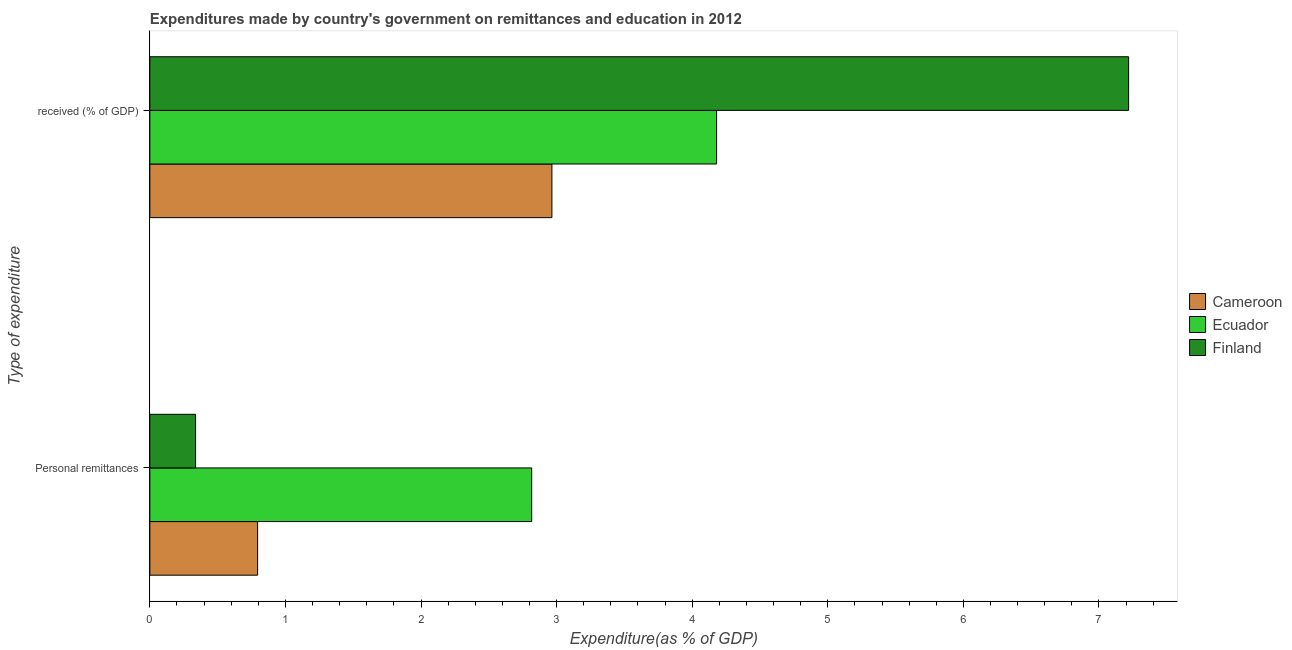Are the number of bars on each tick of the Y-axis equal?
Your response must be concise. Yes. How many bars are there on the 2nd tick from the top?
Offer a very short reply. 3. How many bars are there on the 1st tick from the bottom?
Give a very brief answer. 3. What is the label of the 1st group of bars from the top?
Your answer should be compact.  received (% of GDP). What is the expenditure in education in Ecuador?
Ensure brevity in your answer.  4.18. Across all countries, what is the maximum expenditure in personal remittances?
Provide a short and direct response. 2.82. Across all countries, what is the minimum expenditure in personal remittances?
Provide a short and direct response. 0.34. In which country was the expenditure in education maximum?
Offer a very short reply. Finland. What is the total expenditure in personal remittances in the graph?
Give a very brief answer. 3.95. What is the difference between the expenditure in education in Finland and that in Ecuador?
Give a very brief answer. 3.04. What is the difference between the expenditure in personal remittances in Ecuador and the expenditure in education in Finland?
Your response must be concise. -4.4. What is the average expenditure in education per country?
Offer a terse response. 4.79. What is the difference between the expenditure in personal remittances and expenditure in education in Finland?
Offer a terse response. -6.88. In how many countries, is the expenditure in education greater than 2.2 %?
Your response must be concise. 3. What is the ratio of the expenditure in personal remittances in Ecuador to that in Cameroon?
Give a very brief answer. 3.54. Is the expenditure in education in Cameroon less than that in Ecuador?
Make the answer very short. Yes. What does the 1st bar from the top in Personal remittances represents?
Your response must be concise. Finland. What does the 1st bar from the bottom in Personal remittances represents?
Offer a terse response. Cameroon. How many countries are there in the graph?
Offer a very short reply. 3. Are the values on the major ticks of X-axis written in scientific E-notation?
Ensure brevity in your answer.  No. What is the title of the graph?
Your answer should be compact. Expenditures made by country's government on remittances and education in 2012. Does "Iran" appear as one of the legend labels in the graph?
Your answer should be compact. No. What is the label or title of the X-axis?
Your answer should be compact. Expenditure(as % of GDP). What is the label or title of the Y-axis?
Your answer should be compact. Type of expenditure. What is the Expenditure(as % of GDP) of Cameroon in Personal remittances?
Your answer should be very brief. 0.79. What is the Expenditure(as % of GDP) of Ecuador in Personal remittances?
Your answer should be compact. 2.82. What is the Expenditure(as % of GDP) of Finland in Personal remittances?
Keep it short and to the point. 0.34. What is the Expenditure(as % of GDP) in Cameroon in  received (% of GDP)?
Offer a terse response. 2.97. What is the Expenditure(as % of GDP) in Ecuador in  received (% of GDP)?
Keep it short and to the point. 4.18. What is the Expenditure(as % of GDP) of Finland in  received (% of GDP)?
Your answer should be compact. 7.22. Across all Type of expenditure, what is the maximum Expenditure(as % of GDP) in Cameroon?
Your answer should be compact. 2.97. Across all Type of expenditure, what is the maximum Expenditure(as % of GDP) in Ecuador?
Provide a short and direct response. 4.18. Across all Type of expenditure, what is the maximum Expenditure(as % of GDP) of Finland?
Keep it short and to the point. 7.22. Across all Type of expenditure, what is the minimum Expenditure(as % of GDP) of Cameroon?
Your answer should be compact. 0.79. Across all Type of expenditure, what is the minimum Expenditure(as % of GDP) in Ecuador?
Offer a terse response. 2.82. Across all Type of expenditure, what is the minimum Expenditure(as % of GDP) of Finland?
Your answer should be very brief. 0.34. What is the total Expenditure(as % of GDP) in Cameroon in the graph?
Your answer should be compact. 3.76. What is the total Expenditure(as % of GDP) of Ecuador in the graph?
Make the answer very short. 7. What is the total Expenditure(as % of GDP) in Finland in the graph?
Offer a very short reply. 7.56. What is the difference between the Expenditure(as % of GDP) of Cameroon in Personal remittances and that in  received (% of GDP)?
Offer a very short reply. -2.17. What is the difference between the Expenditure(as % of GDP) of Ecuador in Personal remittances and that in  received (% of GDP)?
Keep it short and to the point. -1.36. What is the difference between the Expenditure(as % of GDP) of Finland in Personal remittances and that in  received (% of GDP)?
Your response must be concise. -6.88. What is the difference between the Expenditure(as % of GDP) of Cameroon in Personal remittances and the Expenditure(as % of GDP) of Ecuador in  received (% of GDP)?
Provide a succinct answer. -3.39. What is the difference between the Expenditure(as % of GDP) in Cameroon in Personal remittances and the Expenditure(as % of GDP) in Finland in  received (% of GDP)?
Give a very brief answer. -6.42. What is the difference between the Expenditure(as % of GDP) of Ecuador in Personal remittances and the Expenditure(as % of GDP) of Finland in  received (% of GDP)?
Your response must be concise. -4.4. What is the average Expenditure(as % of GDP) in Cameroon per Type of expenditure?
Offer a terse response. 1.88. What is the average Expenditure(as % of GDP) of Ecuador per Type of expenditure?
Your response must be concise. 3.5. What is the average Expenditure(as % of GDP) in Finland per Type of expenditure?
Make the answer very short. 3.78. What is the difference between the Expenditure(as % of GDP) in Cameroon and Expenditure(as % of GDP) in Ecuador in Personal remittances?
Offer a terse response. -2.02. What is the difference between the Expenditure(as % of GDP) of Cameroon and Expenditure(as % of GDP) of Finland in Personal remittances?
Your answer should be very brief. 0.46. What is the difference between the Expenditure(as % of GDP) of Ecuador and Expenditure(as % of GDP) of Finland in Personal remittances?
Keep it short and to the point. 2.48. What is the difference between the Expenditure(as % of GDP) of Cameroon and Expenditure(as % of GDP) of Ecuador in  received (% of GDP)?
Your response must be concise. -1.21. What is the difference between the Expenditure(as % of GDP) of Cameroon and Expenditure(as % of GDP) of Finland in  received (% of GDP)?
Give a very brief answer. -4.25. What is the difference between the Expenditure(as % of GDP) in Ecuador and Expenditure(as % of GDP) in Finland in  received (% of GDP)?
Make the answer very short. -3.04. What is the ratio of the Expenditure(as % of GDP) of Cameroon in Personal remittances to that in  received (% of GDP)?
Provide a succinct answer. 0.27. What is the ratio of the Expenditure(as % of GDP) in Ecuador in Personal remittances to that in  received (% of GDP)?
Provide a short and direct response. 0.67. What is the ratio of the Expenditure(as % of GDP) of Finland in Personal remittances to that in  received (% of GDP)?
Provide a succinct answer. 0.05. What is the difference between the highest and the second highest Expenditure(as % of GDP) in Cameroon?
Ensure brevity in your answer.  2.17. What is the difference between the highest and the second highest Expenditure(as % of GDP) of Ecuador?
Give a very brief answer. 1.36. What is the difference between the highest and the second highest Expenditure(as % of GDP) of Finland?
Ensure brevity in your answer.  6.88. What is the difference between the highest and the lowest Expenditure(as % of GDP) in Cameroon?
Offer a very short reply. 2.17. What is the difference between the highest and the lowest Expenditure(as % of GDP) in Ecuador?
Give a very brief answer. 1.36. What is the difference between the highest and the lowest Expenditure(as % of GDP) of Finland?
Your answer should be compact. 6.88. 